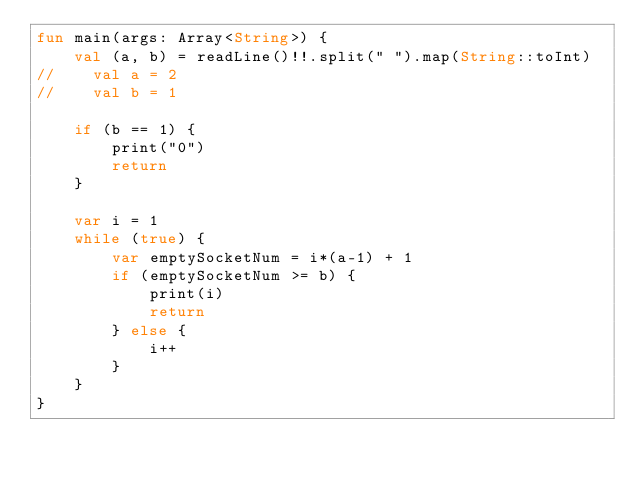Convert code to text. <code><loc_0><loc_0><loc_500><loc_500><_Kotlin_>fun main(args: Array<String>) {
    val (a, b) = readLine()!!.split(" ").map(String::toInt)
//    val a = 2
//    val b = 1

    if (b == 1) {
        print("0")
        return
    }

    var i = 1
    while (true) {
        var emptySocketNum = i*(a-1) + 1
        if (emptySocketNum >= b) {
            print(i)
            return
        } else {
            i++
        }
    }
}</code> 